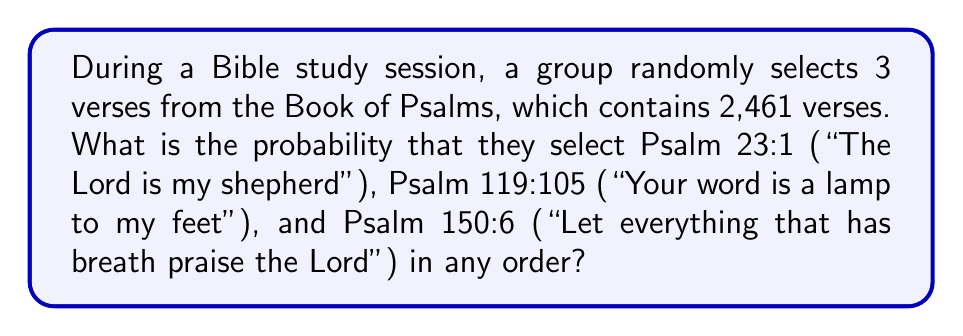Solve this math problem. Let's approach this step-by-step:

1) First, we need to understand that the order of selection doesn't matter. We're just concerned with these three specific verses being chosen out of all possible combinations of 3 verses from Psalms.

2) The total number of ways to choose 3 verses from 2,461 verses is given by the combination formula:

   $$\binom{2461}{3} = \frac{2461!}{3!(2461-3)!} = \frac{2461!}{3!2458!}$$

3) This can be calculated as:
   
   $$\binom{2461}{3} = 2,461 \times 2,460 \times 2,459 \div (3 \times 2 \times 1) = 2,476,915,340$$

4) Now, there is only 1 way to choose these specific 3 verses.

5) Therefore, the probability is:

   $$P = \frac{\text{Favorable outcomes}}{\text{Total outcomes}} = \frac{1}{2,476,915,340}$$

This probability is very small, demonstrating the vast richness of Scripture and the divine guidance that often leads us to specific, meaningful verses during our studies.
Answer: $\frac{1}{2,476,915,340}$ 